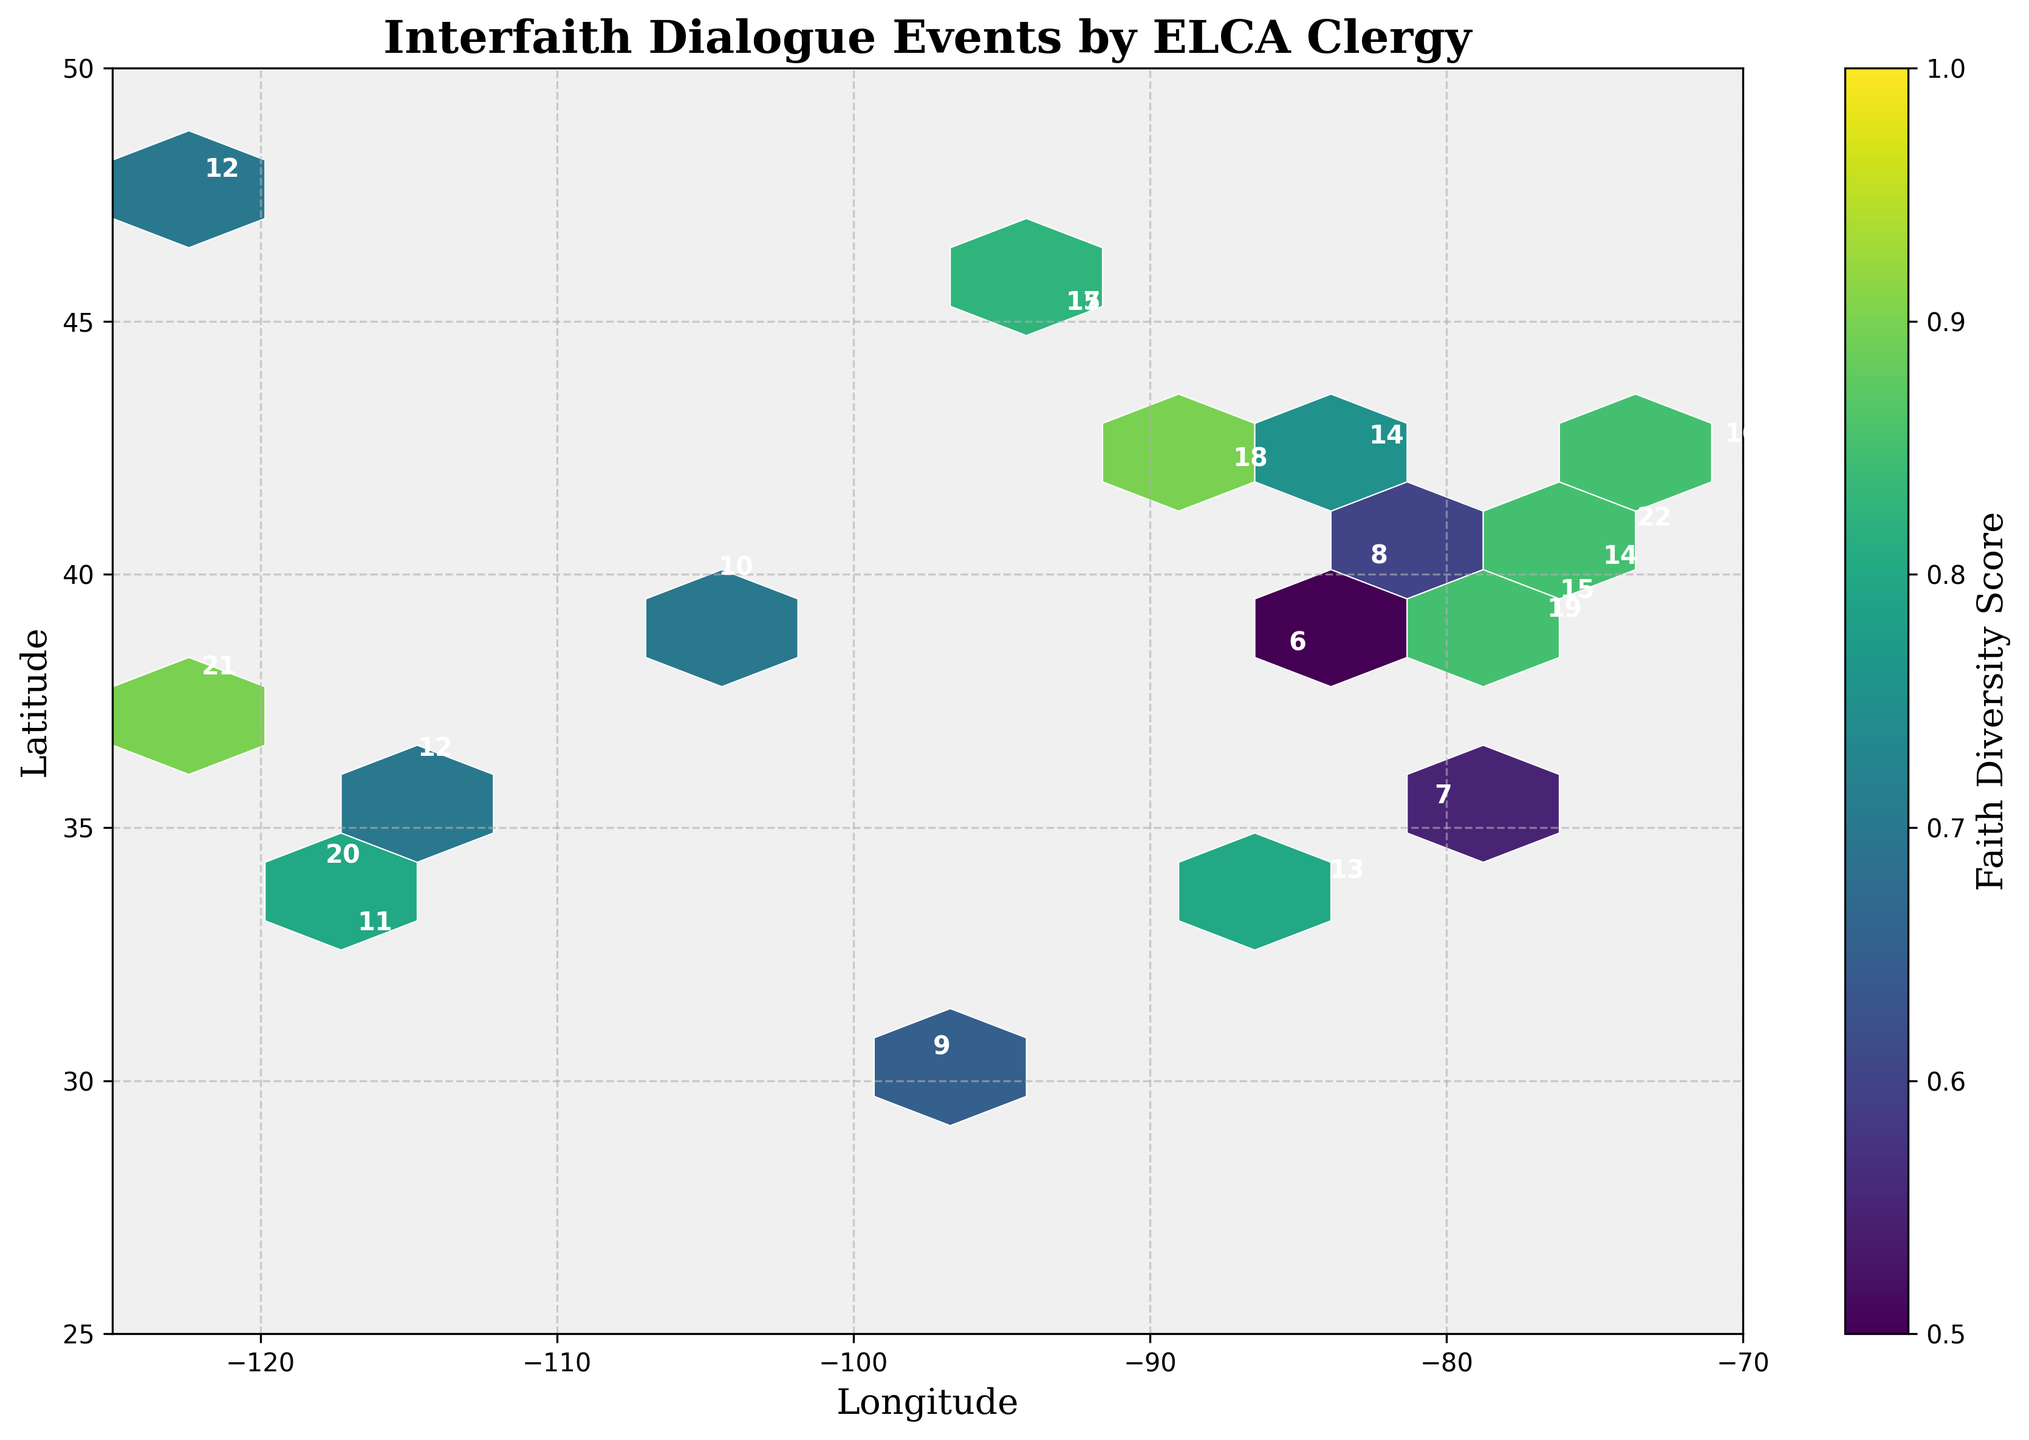What's the title of the figure? The title of the figure is usually prominently displayed at the top of the plot. In this case, the title is "Interfaith Dialogue Events by ELCA Clergy".
Answer: Interfaith Dialogue Events by ELCA Clergy What does the color bar represent? The color bar typically explains the meaning of the colors used in the plot. Here, it represents the "Faith Diversity Score", which measures the diversity of faith traditions involved in the interfaith dialogue events.
Answer: Faith Diversity Score How many interfaith dialogue events involving ELCA clergy occurred in New York City? By locating the point corresponding to New York City on the plot (longitude -74.0060, latitude 40.7128) and looking at the annotation near it, we see that there were 22 events.
Answer: 22 Which city has the highest faith diversity score? The faith diversity score is indicated by the color within the hexbin. The city with coordinates matching the darkest (viridis) hexbin in the plot would have the highest score. Additionally, looking at the diversity scores in the data, New York (0.95) has the highest score.
Answer: New York City How are the event frequency and faith diversity score related geographically? This requires examining the plot to see if areas with high event frequency also have high faith diversity scores based on color intensity. In general, cities with higher event frequency (denser hexbin areas) tend to have darker colors, indicating higher faith diversity scores.
Answer: Higher event frequency areas tend to have higher faith diversity scores What is the longitude range covered in the plot? Longitude values can be derived from the x-axis limits of the plot. They range from -125 to -70 based on the x-axis labels.
Answer: -125 to -70 How many cities have an event frequency greater than 15? By examining the plot annotations or data points directly, cities with event frequency values greater than 15 are Minneapolis (2 points), Chicago, Los Angeles, New York, Boston, Washington D.C., and San Francisco—7 in total.
Answer: 7 Which city in the western United States has the highest event frequency? Cities in the western United States on the plot include Los Angeles, San Francisco, and Seattle. Among these, Los Angeles has an event frequency of 20, which is the highest.
Answer: Los Angeles What's the faith diversity score for Philadelphia? For Philadelphia (longitude -75.1652, latitude 39.9526), the annotated data point shows an event frequency of 14 and a faith diversity score of 0.75.
Answer: 0.75 